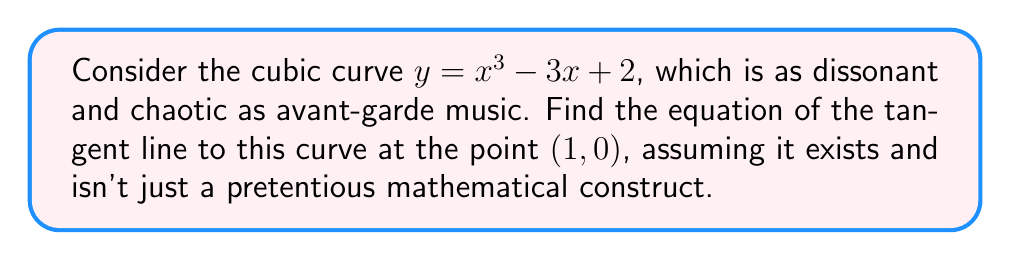Give your solution to this math problem. 1) To find the tangent line, we need to calculate the slope at the given point. The slope is given by the derivative of the function at that point.

2) Let's derive the function $f(x) = x^3 - 3x + 2$:
   $$f'(x) = 3x^2 - 3$$

3) Now, we evaluate the derivative at $x = 1$:
   $$f'(1) = 3(1)^2 - 3 = 3 - 3 = 0$$

4) The slope of the tangent line at $(1, 0)$ is 0. This means the tangent line is horizontal, much like the flat, uninspired nature of some avant-garde compositions.

5) The equation of a line is $y = mx + b$, where $m$ is the slope and $b$ is the y-intercept.
   We know $m = 0$, so our equation is of the form $y = b$.

6) To find $b$, we use the point $(1, 0)$ that the line passes through:
   $0 = b$

7) Therefore, the equation of the tangent line is $y = 0$.
Answer: $y = 0$ 